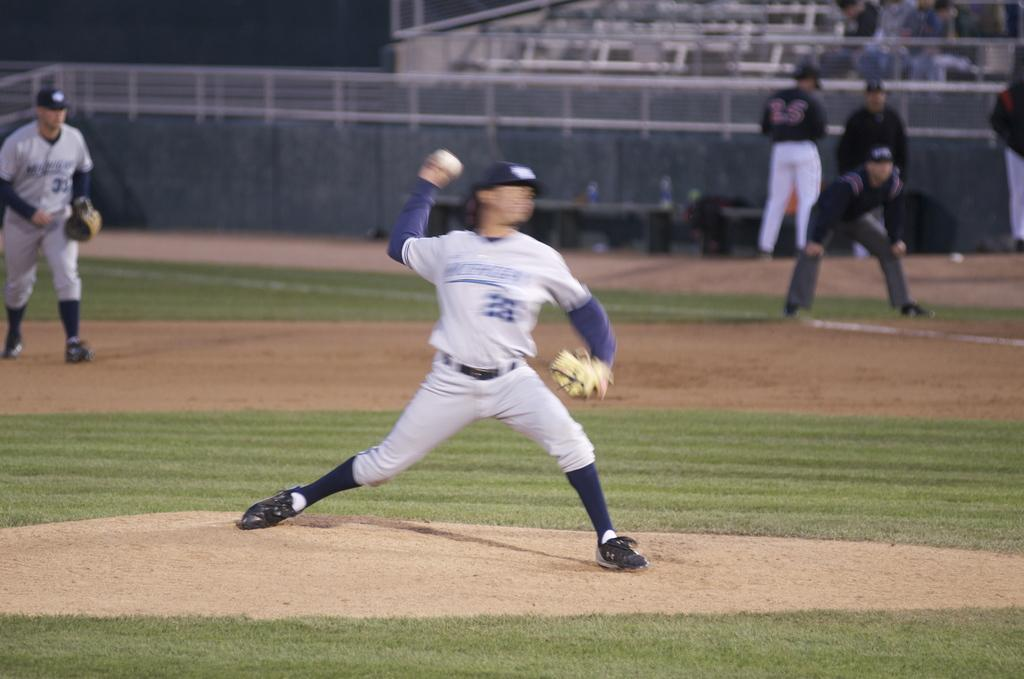What is the person in the image doing? The person in the image is throwing a ball. Can you describe the setting of the image? There are people and railing in the background of the image, as well as a bottle and benches. How many people are visible in the image? There is one person throwing a ball, and there are people in the background, but the exact number is not specified. What type of apparel is the robin wearing in the image? There is no robin present in the image. --- Facts: 1. There is a person in the image. 2. The person is holding a book. 3. The book has a blue cover. 4. The person is sitting on a chair. 5. There is a table next to the chair. Absurd Topics: unicorn, rainbow, stars Conversation: What is the person in the image doing? The person in the image is holding a book. Can you describe the book in the image? The book in the image has a blue cover. What is the person's position in the image? The person is sitting on a chair. What is located next to the chair in the image? There is a table next to the chair in the image. Reasoning: Let's think step by step in order to produce the conversation. We start by identifying the main action in the image, which is the person holding a book. Next, we describe the book in the image, mentioning the color of the book's cover. Then, we observe the person's position in the image, noting that they are sitting on a chair. Finally, we describe the object located next to the chair in the image, which is a table. Absurd Question/Answer: How many unicorns can be seen playing with the stars in the image? There are no unicorns or stars present in the image. 